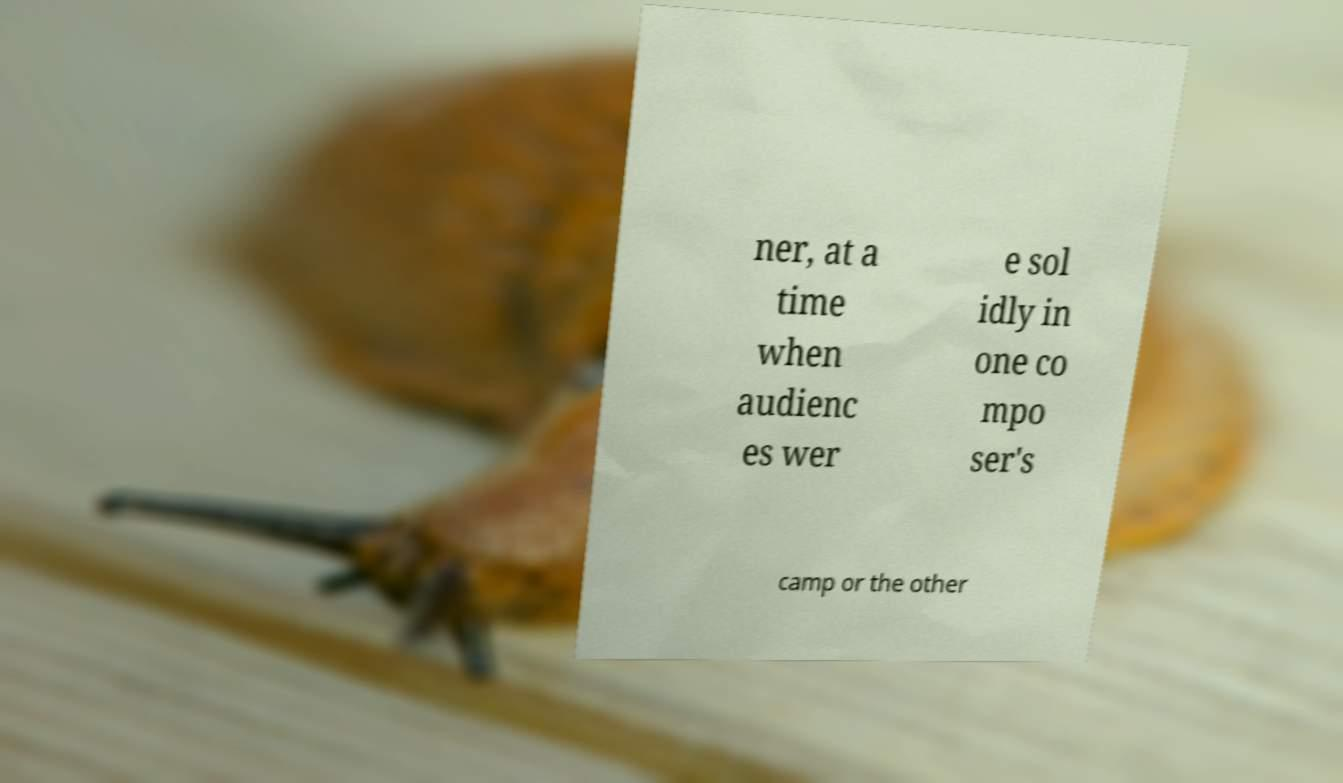Can you accurately transcribe the text from the provided image for me? ner, at a time when audienc es wer e sol idly in one co mpo ser's camp or the other 